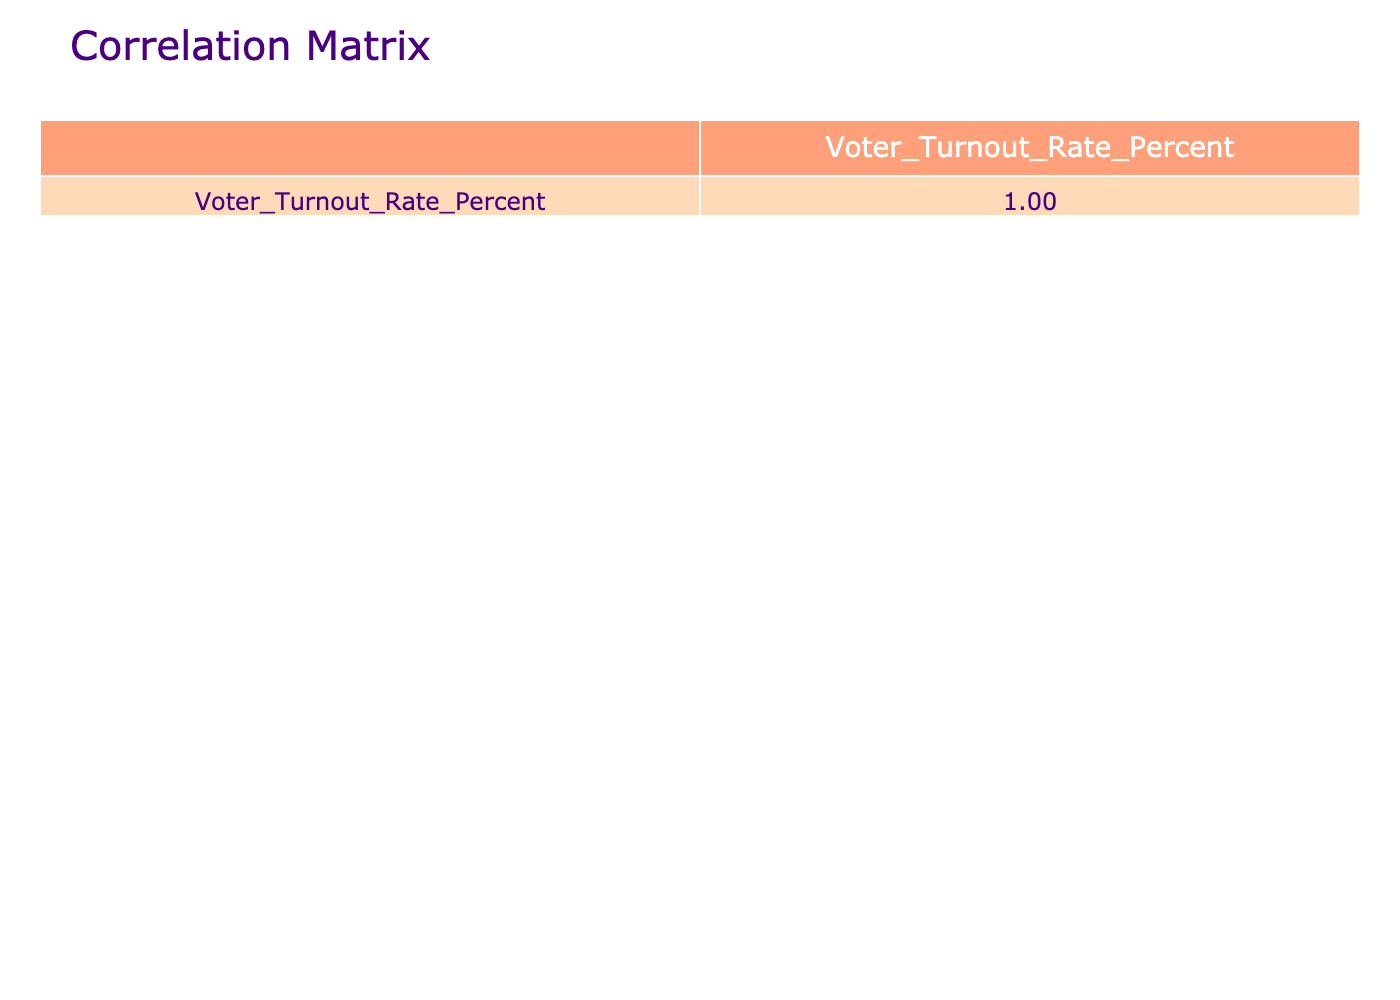What is the voter turnout rate for the age group 55-64? According to the table, the voter turnout rate for the age group 55-64 is listed as 88.7 percent.
Answer: 88.7 Which age group has the highest voter turnout rate? By examining the table, the age group 65+ has the highest voter turnout rate at 90.2 percent.
Answer: 65+ What is the voter turnout rate for the age group 25-34 compared to the age group 35-44? The voter turnout rate for 25-34 is 71.1 percent, while for 35-44, it is 82.3 percent. Comparing, 82.3 - 71.1 = 11.2, thus 35-44 has 11.2 percent higher turnout than 25-34.
Answer: 11.2 percent Is the voter turnout rate for the age group 18-24 higher than 70 percent? From the table, the voter turnout rate for the age group 18-24 is 67.5 percent, which is lower than 70 percent.
Answer: No What is the average voter turnout rate for the age groups 18-24 and 25-34? To find the average, first sum the rates for these age groups: 67.5 + 71.1 = 138.6. Then divide by the number of groups, which is 2: 138.6 / 2 = 69.3.
Answer: 69.3 Does there seem to be a correlation between age and voter turnout rate based on the table? By observing the table, we can see that as age increases, voter turnout rates also generally increase, suggesting a positive correlation.
Answer: Yes What is the difference in voter turnout rate between the age groups 45-54 and 65+? The voter turnout rate for 45-54 is 85.6 percent, and for 65+, it is 90.2 percent. The difference is 90.2 - 85.6 = 4.6 percent, meaning 65+ has a higher turnout.
Answer: 4.6 percent Is the voter turnout rate for the age group 35-44 less than the overall average of the age groups? The age group 35-44 has a voter turnout rate of 82.3 percent; if we sum all the rates (67.5 + 71.1 + 82.3 + 85.6 + 88.7 + 90.2 = 485.4) and divide by 6, we get an average of 80.9 percent. Thus, 82.3 is greater than 80.9.
Answer: No What is the trend in voter turnout rates as the age group increases from 18-24 to 65+? The table shows that each successive age group has a higher voter turnout rate than the previous one, indicating an upward trend in voter turnout as age increases.
Answer: Upward trend 